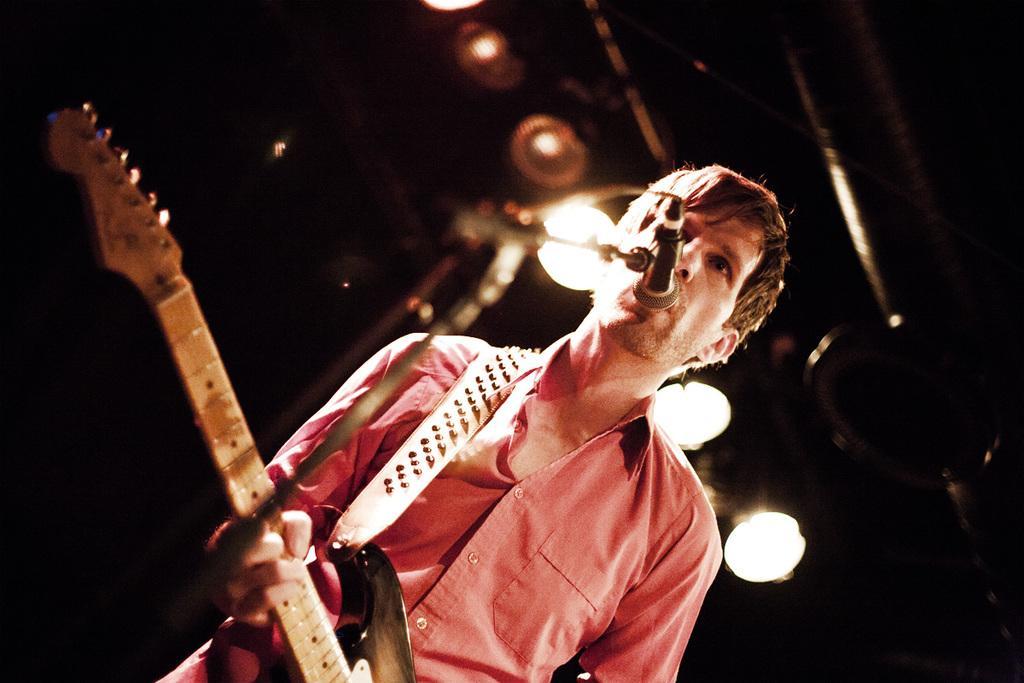Could you give a brief overview of what you see in this image? In this picture there is a boy who is holding the guitar in front of the mic and there are spotlights in the above area of the image. 